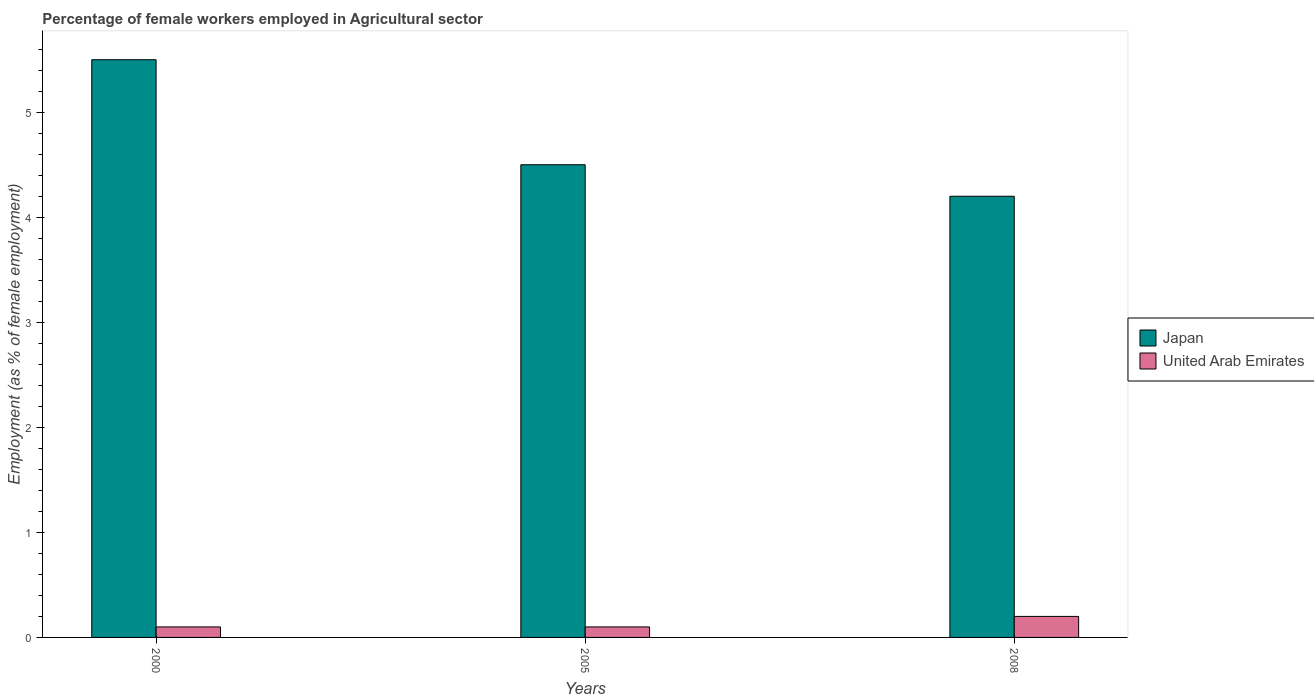How many groups of bars are there?
Your answer should be compact. 3. What is the label of the 1st group of bars from the left?
Provide a succinct answer. 2000. What is the percentage of females employed in Agricultural sector in Japan in 2005?
Provide a succinct answer. 4.5. Across all years, what is the maximum percentage of females employed in Agricultural sector in United Arab Emirates?
Offer a terse response. 0.2. Across all years, what is the minimum percentage of females employed in Agricultural sector in Japan?
Offer a very short reply. 4.2. In which year was the percentage of females employed in Agricultural sector in United Arab Emirates minimum?
Offer a terse response. 2000. What is the total percentage of females employed in Agricultural sector in United Arab Emirates in the graph?
Make the answer very short. 0.4. What is the difference between the percentage of females employed in Agricultural sector in United Arab Emirates in 2005 and that in 2008?
Make the answer very short. -0.1. What is the difference between the percentage of females employed in Agricultural sector in Japan in 2008 and the percentage of females employed in Agricultural sector in United Arab Emirates in 2000?
Your answer should be compact. 4.1. What is the average percentage of females employed in Agricultural sector in Japan per year?
Give a very brief answer. 4.73. In the year 2008, what is the difference between the percentage of females employed in Agricultural sector in Japan and percentage of females employed in Agricultural sector in United Arab Emirates?
Make the answer very short. 4. In how many years, is the percentage of females employed in Agricultural sector in Japan greater than 1.2 %?
Offer a very short reply. 3. What is the ratio of the percentage of females employed in Agricultural sector in Japan in 2000 to that in 2005?
Provide a succinct answer. 1.22. What is the difference between the highest and the lowest percentage of females employed in Agricultural sector in Japan?
Offer a very short reply. 1.3. In how many years, is the percentage of females employed in Agricultural sector in United Arab Emirates greater than the average percentage of females employed in Agricultural sector in United Arab Emirates taken over all years?
Provide a succinct answer. 1. What does the 1st bar from the left in 2005 represents?
Provide a succinct answer. Japan. How many bars are there?
Your answer should be compact. 6. Are all the bars in the graph horizontal?
Offer a terse response. No. How many years are there in the graph?
Provide a succinct answer. 3. Are the values on the major ticks of Y-axis written in scientific E-notation?
Offer a very short reply. No. Does the graph contain any zero values?
Provide a succinct answer. No. How are the legend labels stacked?
Make the answer very short. Vertical. What is the title of the graph?
Your answer should be compact. Percentage of female workers employed in Agricultural sector. Does "Iceland" appear as one of the legend labels in the graph?
Provide a succinct answer. No. What is the label or title of the Y-axis?
Your answer should be very brief. Employment (as % of female employment). What is the Employment (as % of female employment) in United Arab Emirates in 2000?
Ensure brevity in your answer.  0.1. What is the Employment (as % of female employment) of United Arab Emirates in 2005?
Provide a short and direct response. 0.1. What is the Employment (as % of female employment) in Japan in 2008?
Make the answer very short. 4.2. What is the Employment (as % of female employment) of United Arab Emirates in 2008?
Your response must be concise. 0.2. Across all years, what is the maximum Employment (as % of female employment) of United Arab Emirates?
Your response must be concise. 0.2. Across all years, what is the minimum Employment (as % of female employment) in Japan?
Offer a terse response. 4.2. Across all years, what is the minimum Employment (as % of female employment) in United Arab Emirates?
Provide a short and direct response. 0.1. What is the total Employment (as % of female employment) of United Arab Emirates in the graph?
Ensure brevity in your answer.  0.4. What is the difference between the Employment (as % of female employment) of United Arab Emirates in 2000 and that in 2005?
Give a very brief answer. 0. What is the difference between the Employment (as % of female employment) of Japan in 2000 and that in 2008?
Make the answer very short. 1.3. What is the difference between the Employment (as % of female employment) of United Arab Emirates in 2005 and that in 2008?
Keep it short and to the point. -0.1. What is the difference between the Employment (as % of female employment) in Japan in 2000 and the Employment (as % of female employment) in United Arab Emirates in 2005?
Provide a succinct answer. 5.4. What is the difference between the Employment (as % of female employment) of Japan in 2005 and the Employment (as % of female employment) of United Arab Emirates in 2008?
Ensure brevity in your answer.  4.3. What is the average Employment (as % of female employment) of Japan per year?
Ensure brevity in your answer.  4.73. What is the average Employment (as % of female employment) of United Arab Emirates per year?
Offer a very short reply. 0.13. In the year 2000, what is the difference between the Employment (as % of female employment) of Japan and Employment (as % of female employment) of United Arab Emirates?
Offer a terse response. 5.4. What is the ratio of the Employment (as % of female employment) of Japan in 2000 to that in 2005?
Give a very brief answer. 1.22. What is the ratio of the Employment (as % of female employment) of Japan in 2000 to that in 2008?
Keep it short and to the point. 1.31. What is the ratio of the Employment (as % of female employment) in Japan in 2005 to that in 2008?
Offer a terse response. 1.07. What is the ratio of the Employment (as % of female employment) of United Arab Emirates in 2005 to that in 2008?
Offer a terse response. 0.5. What is the difference between the highest and the lowest Employment (as % of female employment) in Japan?
Keep it short and to the point. 1.3. 